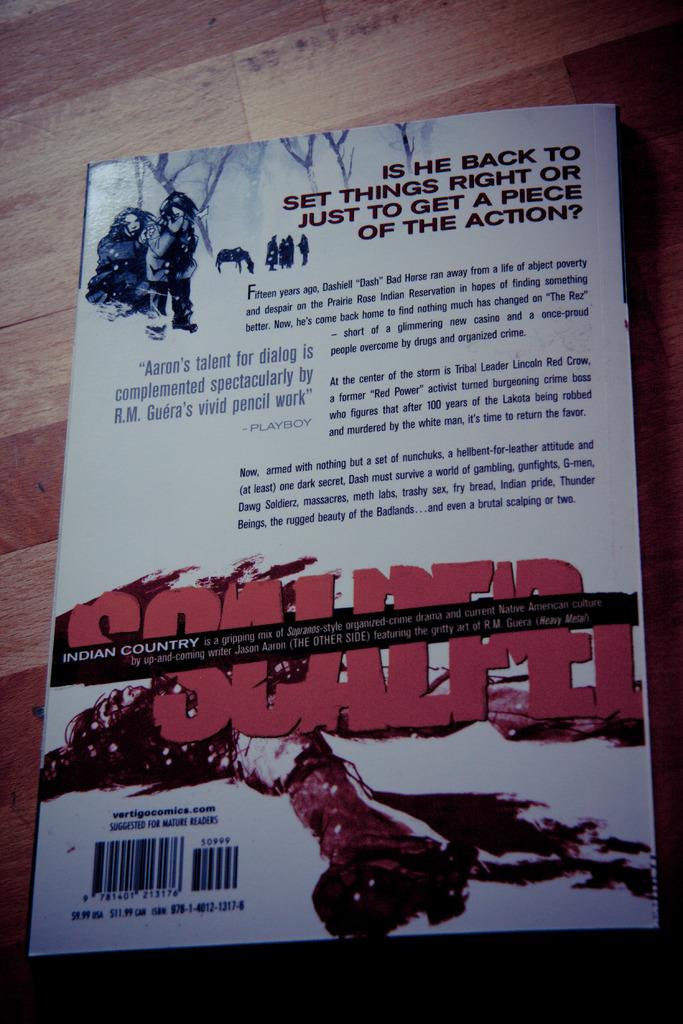What are the first four words printed at the top of this book cover?
Provide a short and direct response. Is he back to. What is the website listed on the book?
Make the answer very short. Vertigocomics.com. 